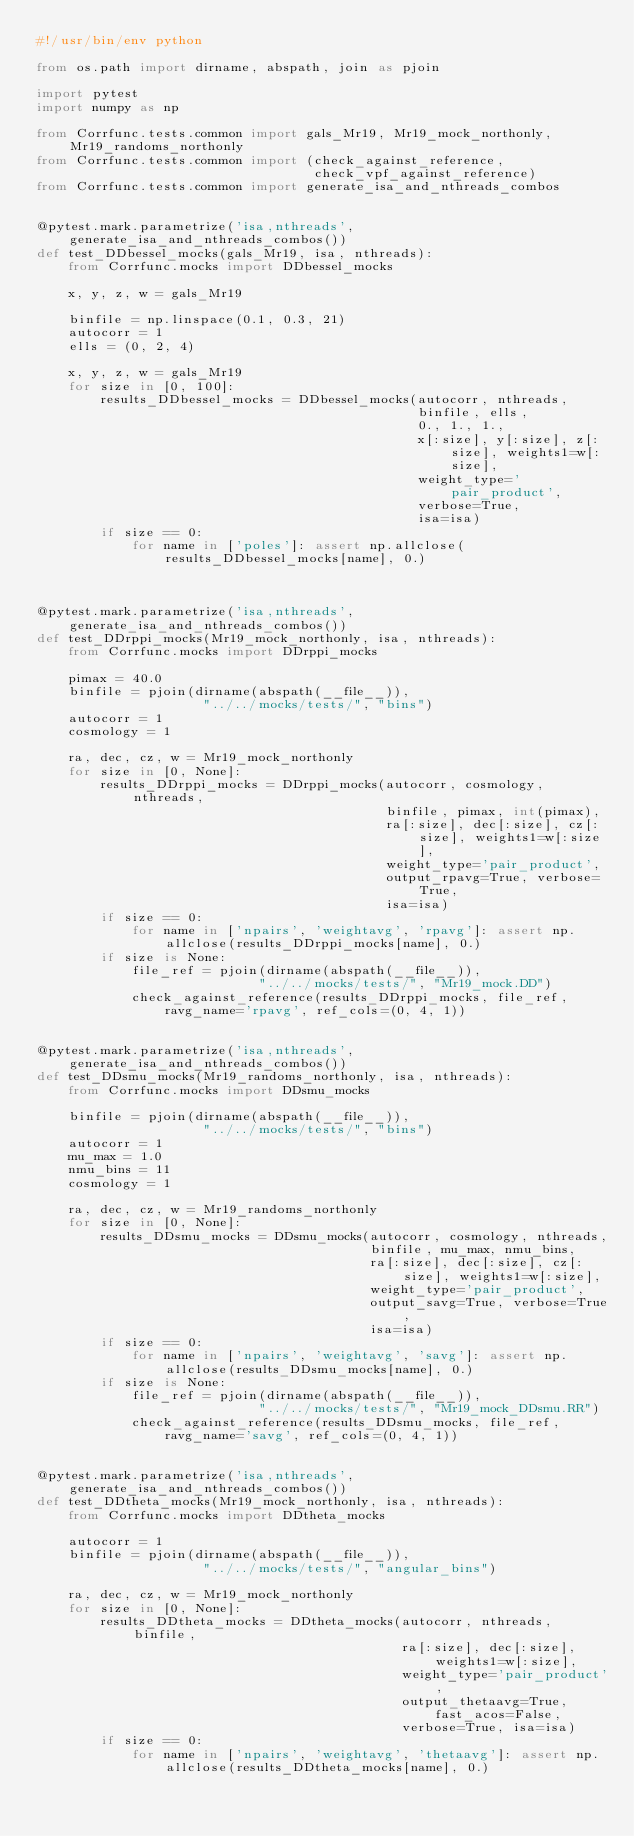Convert code to text. <code><loc_0><loc_0><loc_500><loc_500><_Python_>#!/usr/bin/env python

from os.path import dirname, abspath, join as pjoin

import pytest
import numpy as np

from Corrfunc.tests.common import gals_Mr19, Mr19_mock_northonly, Mr19_randoms_northonly
from Corrfunc.tests.common import (check_against_reference,
                                   check_vpf_against_reference)
from Corrfunc.tests.common import generate_isa_and_nthreads_combos


@pytest.mark.parametrize('isa,nthreads', generate_isa_and_nthreads_combos())
def test_DDbessel_mocks(gals_Mr19, isa, nthreads):
    from Corrfunc.mocks import DDbessel_mocks

    x, y, z, w = gals_Mr19

    binfile = np.linspace(0.1, 0.3, 21)
    autocorr = 1
    ells = (0, 2, 4)

    x, y, z, w = gals_Mr19
    for size in [0, 100]:
        results_DDbessel_mocks = DDbessel_mocks(autocorr, nthreads,
                                                binfile, ells,
                                                0., 1., 1.,
                                                x[:size], y[:size], z[:size], weights1=w[:size],
                                                weight_type='pair_product',
                                                verbose=True,
                                                isa=isa)
        if size == 0:
            for name in ['poles']: assert np.allclose(results_DDbessel_mocks[name], 0.)



@pytest.mark.parametrize('isa,nthreads', generate_isa_and_nthreads_combos())
def test_DDrppi_mocks(Mr19_mock_northonly, isa, nthreads):
    from Corrfunc.mocks import DDrppi_mocks

    pimax = 40.0
    binfile = pjoin(dirname(abspath(__file__)),
                     "../../mocks/tests/", "bins")
    autocorr = 1
    cosmology = 1

    ra, dec, cz, w = Mr19_mock_northonly
    for size in [0, None]:
        results_DDrppi_mocks = DDrppi_mocks(autocorr, cosmology, nthreads,
                                            binfile, pimax, int(pimax),
                                            ra[:size], dec[:size], cz[:size], weights1=w[:size],
                                            weight_type='pair_product',
                                            output_rpavg=True, verbose=True,
                                            isa=isa)
        if size == 0:
            for name in ['npairs', 'weightavg', 'rpavg']: assert np.allclose(results_DDrppi_mocks[name], 0.)
        if size is None:
            file_ref = pjoin(dirname(abspath(__file__)),
                            "../../mocks/tests/", "Mr19_mock.DD")
            check_against_reference(results_DDrppi_mocks, file_ref, ravg_name='rpavg', ref_cols=(0, 4, 1))


@pytest.mark.parametrize('isa,nthreads', generate_isa_and_nthreads_combos())
def test_DDsmu_mocks(Mr19_randoms_northonly, isa, nthreads):
    from Corrfunc.mocks import DDsmu_mocks

    binfile = pjoin(dirname(abspath(__file__)),
                     "../../mocks/tests/", "bins")
    autocorr = 1
    mu_max = 1.0
    nmu_bins = 11
    cosmology = 1

    ra, dec, cz, w = Mr19_randoms_northonly
    for size in [0, None]:
        results_DDsmu_mocks = DDsmu_mocks(autocorr, cosmology, nthreads,
                                          binfile, mu_max, nmu_bins,
                                          ra[:size], dec[:size], cz[:size], weights1=w[:size],
                                          weight_type='pair_product',
                                          output_savg=True, verbose=True,
                                          isa=isa)
        if size == 0:
            for name in ['npairs', 'weightavg', 'savg']: assert np.allclose(results_DDsmu_mocks[name], 0.)
        if size is None:
            file_ref = pjoin(dirname(abspath(__file__)),
                            "../../mocks/tests/", "Mr19_mock_DDsmu.RR")
            check_against_reference(results_DDsmu_mocks, file_ref, ravg_name='savg', ref_cols=(0, 4, 1))


@pytest.mark.parametrize('isa,nthreads', generate_isa_and_nthreads_combos())
def test_DDtheta_mocks(Mr19_mock_northonly, isa, nthreads):
    from Corrfunc.mocks import DDtheta_mocks

    autocorr = 1
    binfile = pjoin(dirname(abspath(__file__)),
                     "../../mocks/tests/", "angular_bins")

    ra, dec, cz, w = Mr19_mock_northonly
    for size in [0, None]:
        results_DDtheta_mocks = DDtheta_mocks(autocorr, nthreads, binfile,
                                              ra[:size], dec[:size], weights1=w[:size],
                                              weight_type='pair_product',
                                              output_thetaavg=True, fast_acos=False,
                                              verbose=True, isa=isa)
        if size == 0:
            for name in ['npairs', 'weightavg', 'thetaavg']: assert np.allclose(results_DDtheta_mocks[name], 0.)</code> 